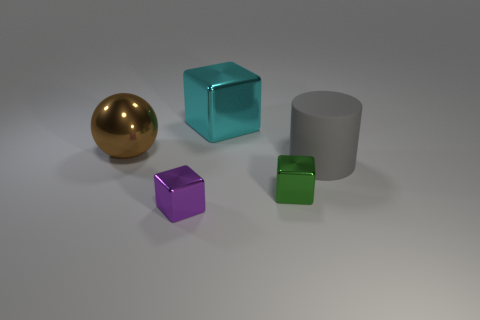Add 3 small blue objects. How many objects exist? 8 Subtract all blocks. How many objects are left? 2 Add 5 big rubber objects. How many big rubber objects are left? 6 Add 4 big things. How many big things exist? 7 Subtract 0 gray cubes. How many objects are left? 5 Subtract all large yellow rubber cylinders. Subtract all tiny blocks. How many objects are left? 3 